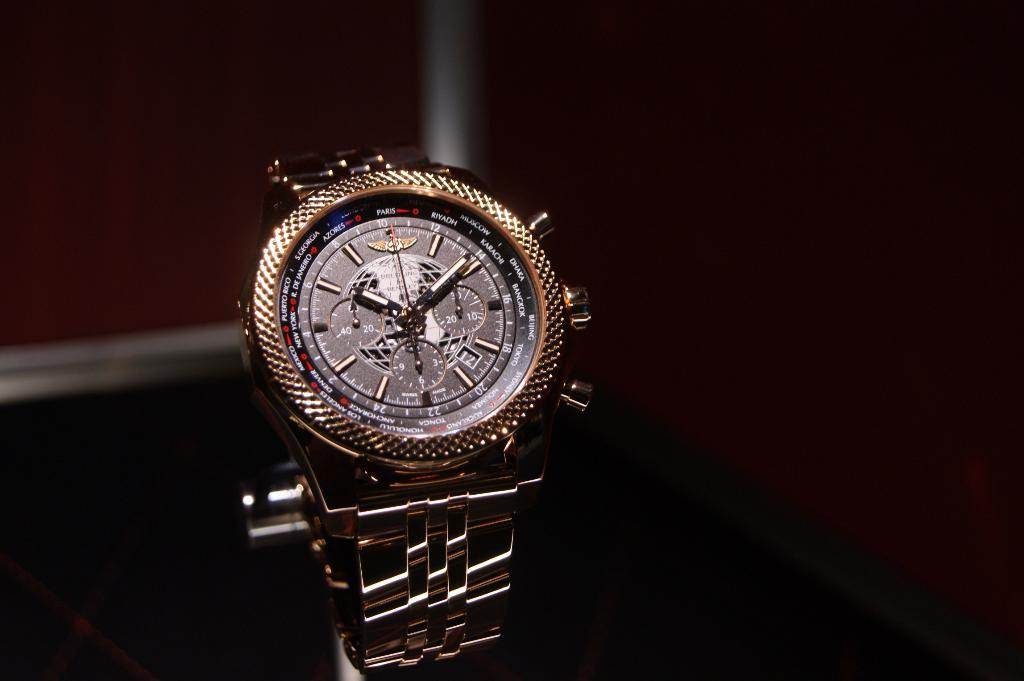Provide a one-sentence caption for the provided image. a watch with the numbers 1 to 12 on the front. 